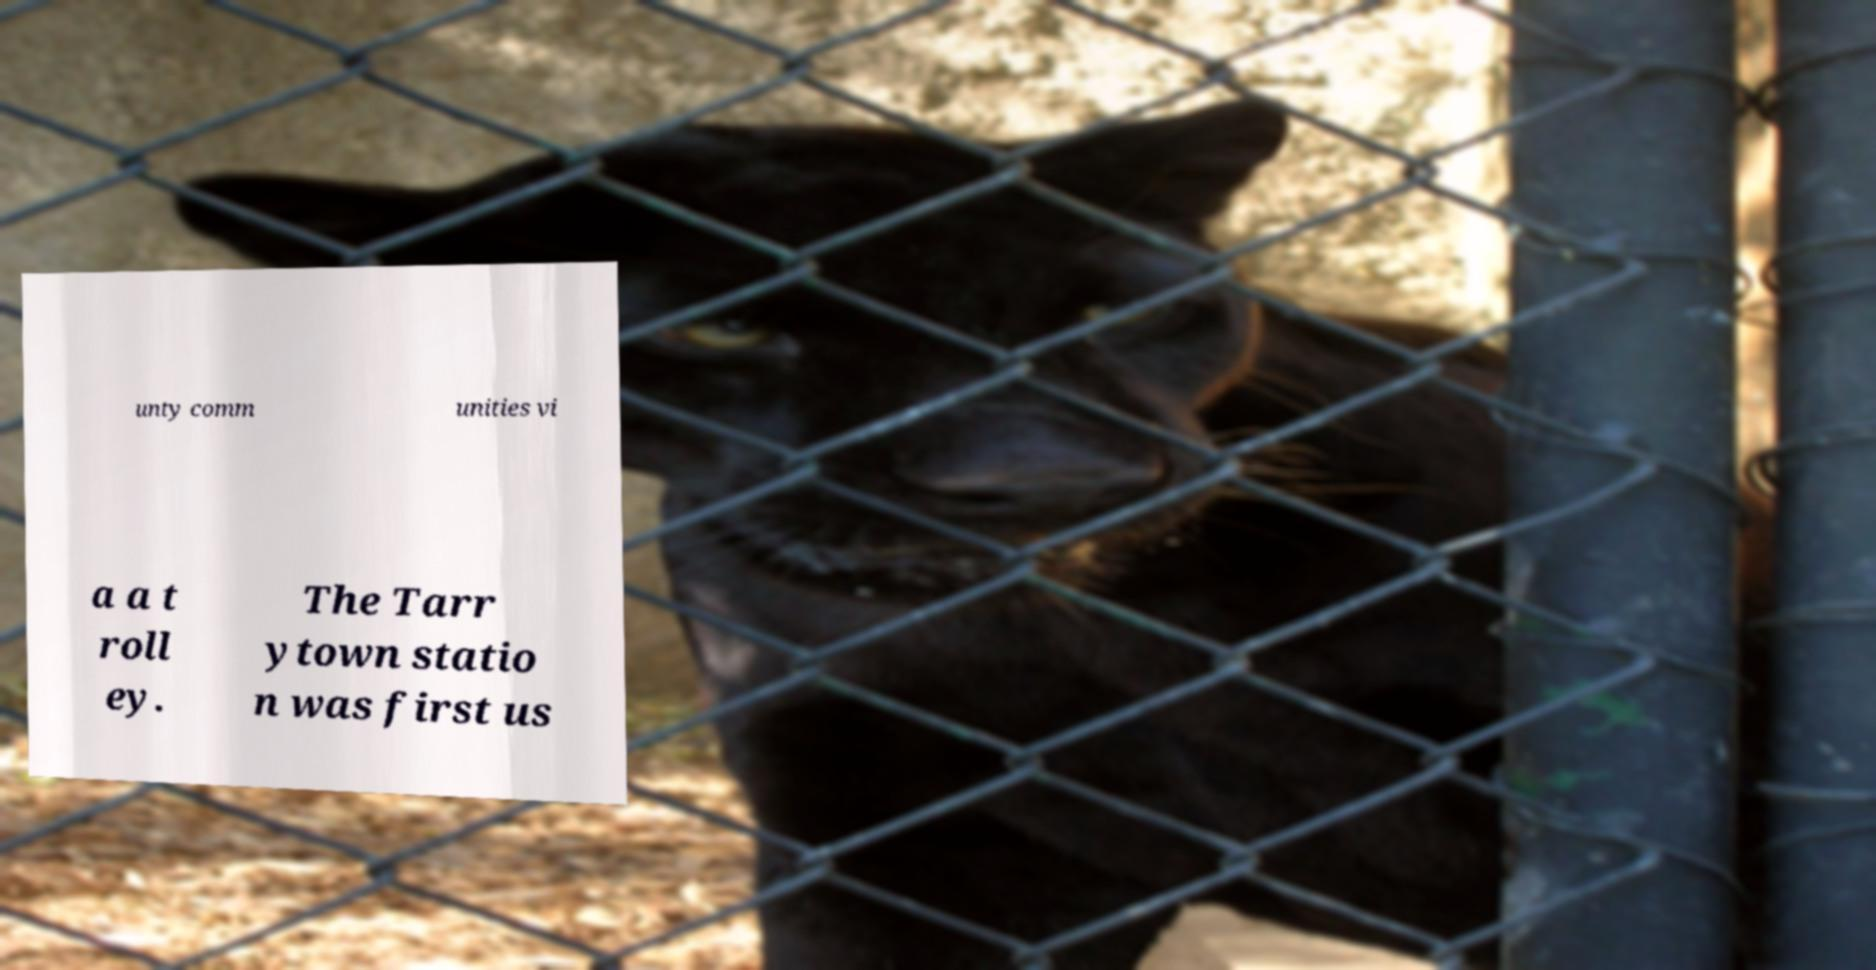For documentation purposes, I need the text within this image transcribed. Could you provide that? unty comm unities vi a a t roll ey. The Tarr ytown statio n was first us 